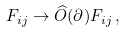Convert formula to latex. <formula><loc_0><loc_0><loc_500><loc_500>F _ { i j } \rightarrow \widehat { O } ( \partial ) F _ { i j } \, ,</formula> 